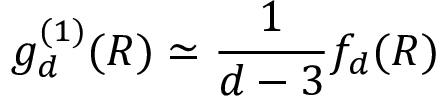Convert formula to latex. <formula><loc_0><loc_0><loc_500><loc_500>g _ { d } ^ { ( 1 ) } ( R ) \simeq \frac { 1 } { d - 3 } f _ { d } ( R )</formula> 